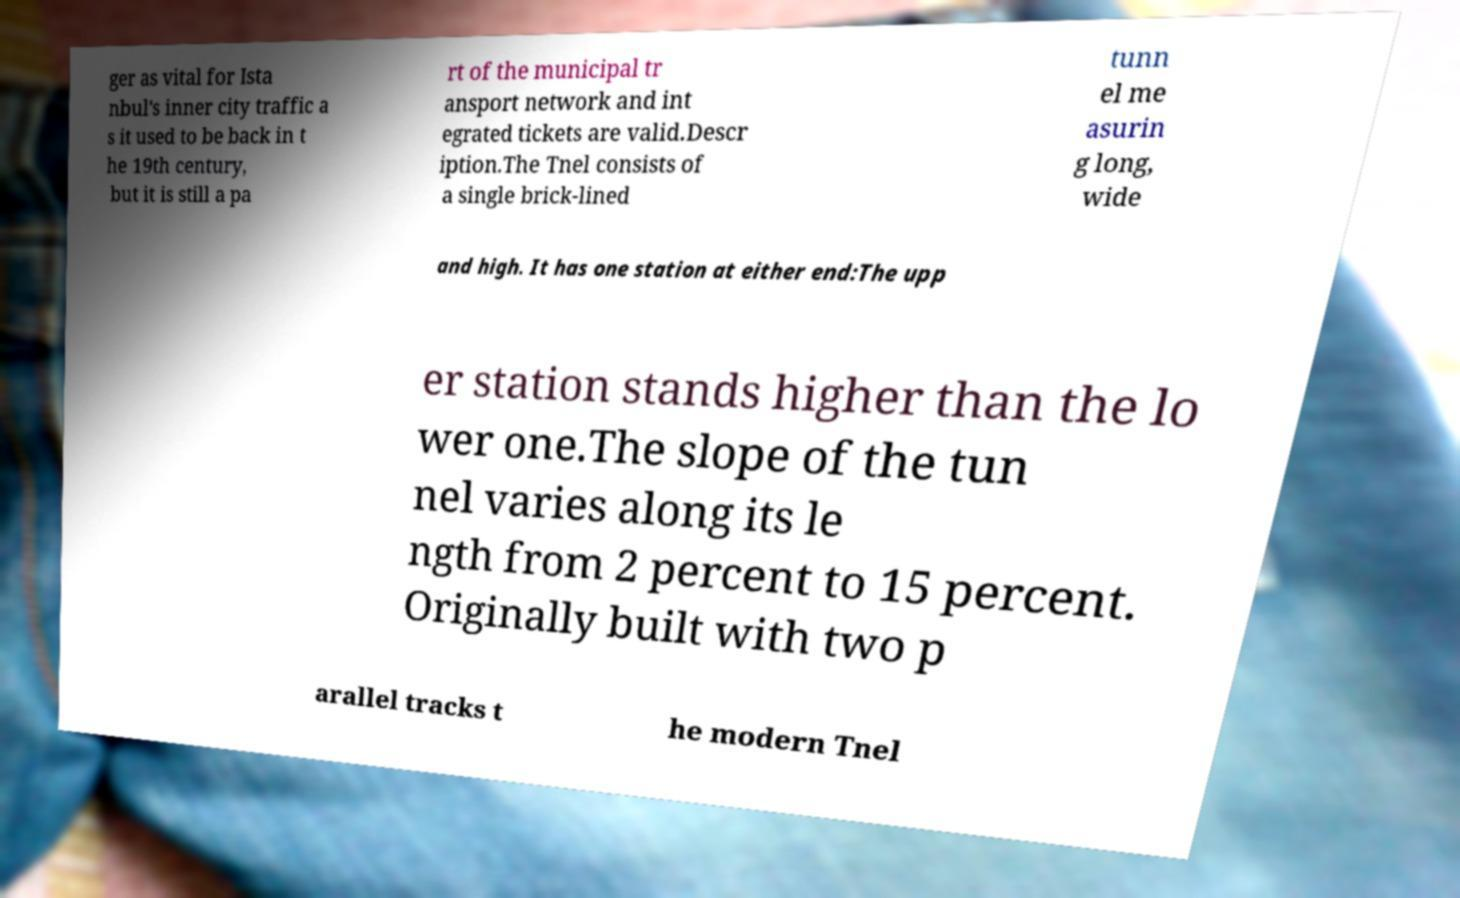I need the written content from this picture converted into text. Can you do that? ger as vital for Ista nbul's inner city traffic a s it used to be back in t he 19th century, but it is still a pa rt of the municipal tr ansport network and int egrated tickets are valid.Descr iption.The Tnel consists of a single brick-lined tunn el me asurin g long, wide and high. It has one station at either end:The upp er station stands higher than the lo wer one.The slope of the tun nel varies along its le ngth from 2 percent to 15 percent. Originally built with two p arallel tracks t he modern Tnel 